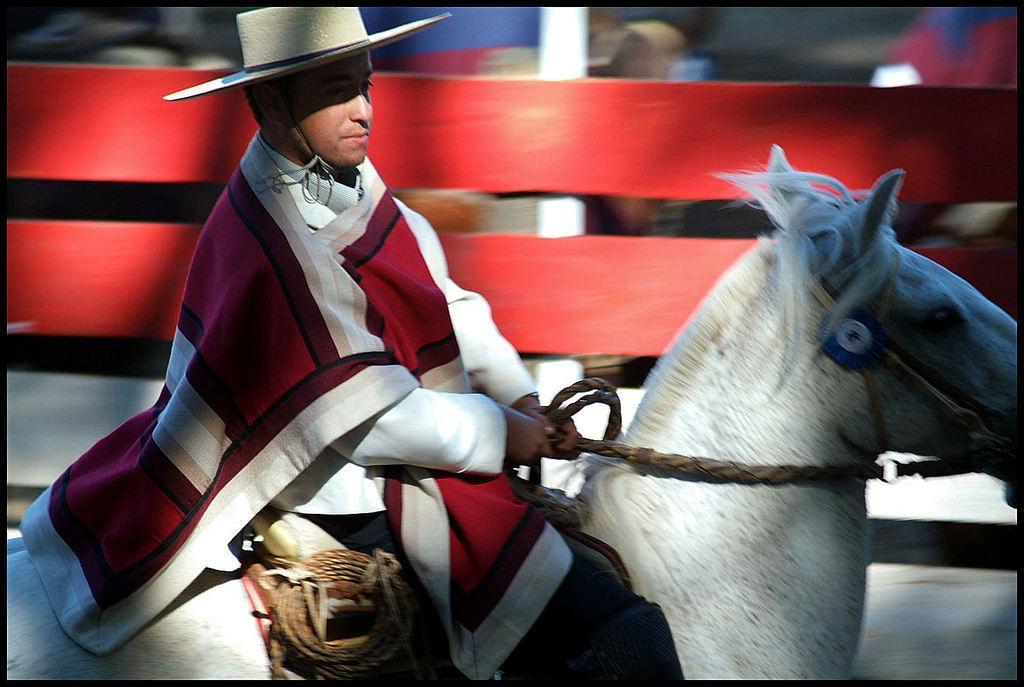Can you describe this image briefly? As we can see in the image there is a man sitting on horse. 